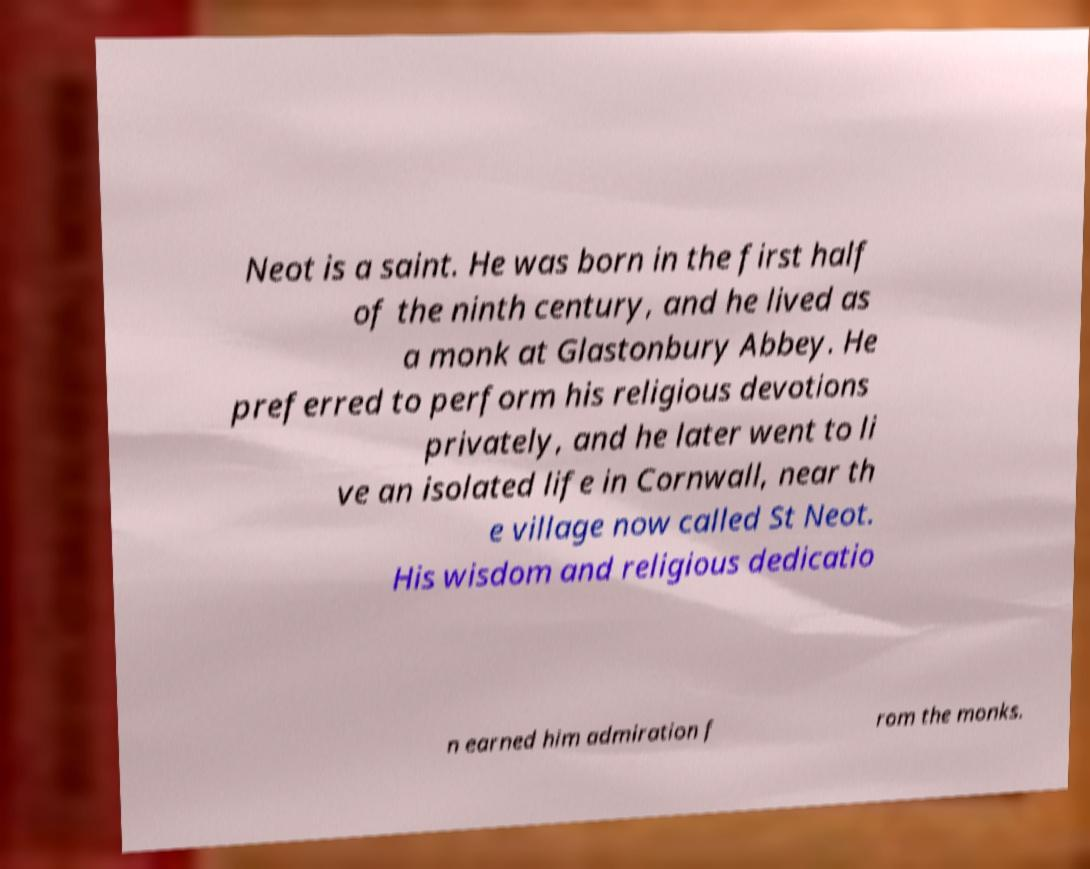Could you extract and type out the text from this image? Neot is a saint. He was born in the first half of the ninth century, and he lived as a monk at Glastonbury Abbey. He preferred to perform his religious devotions privately, and he later went to li ve an isolated life in Cornwall, near th e village now called St Neot. His wisdom and religious dedicatio n earned him admiration f rom the monks. 